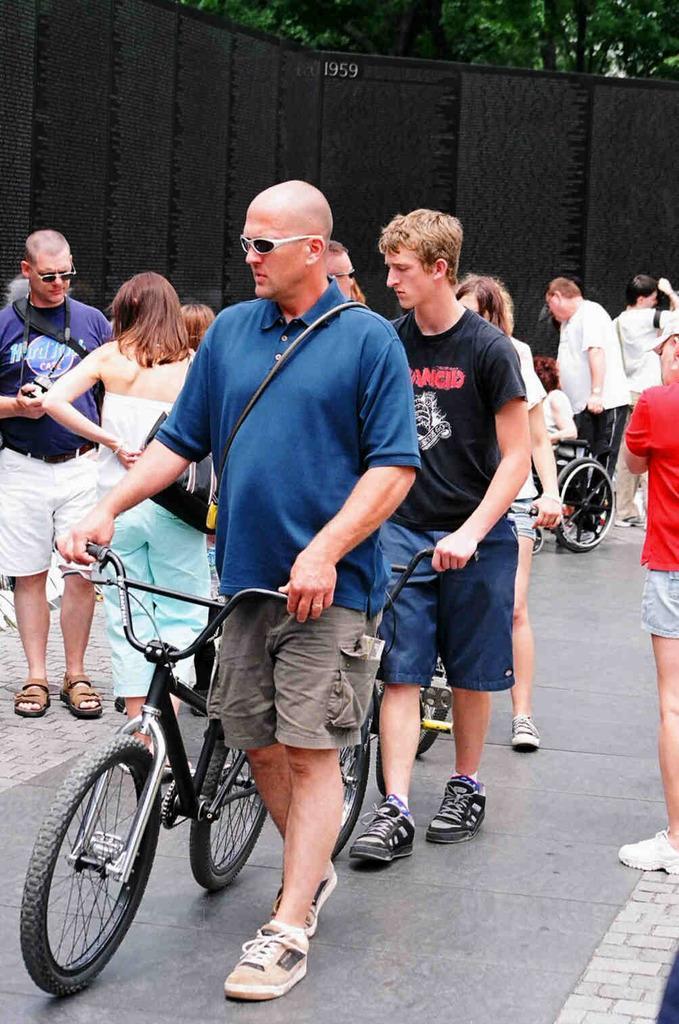In one or two sentences, can you explain what this image depicts? In this image I can see a person wearing blue t shirt, short and shoe is standing on the road and holding a bicycle and I can see another person wearing black t shirt, short and black shoe is standing and holding a bicycle. In the background I can see few other persons standing, the black colored sheet and few trees. 